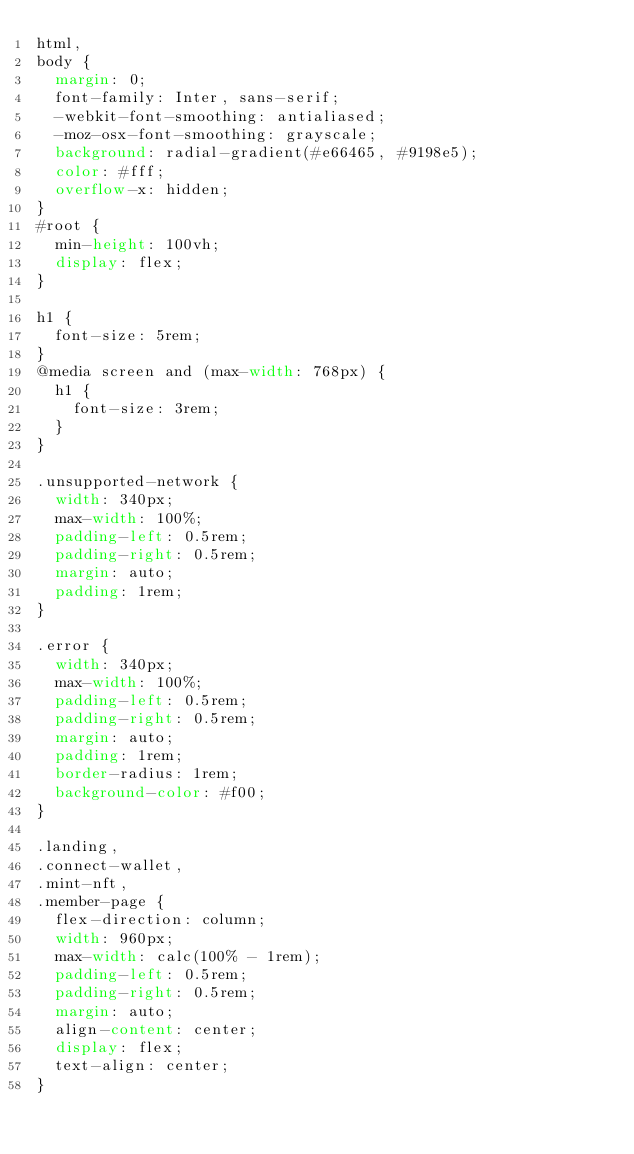<code> <loc_0><loc_0><loc_500><loc_500><_CSS_>html,
body {
  margin: 0;
  font-family: Inter, sans-serif;
  -webkit-font-smoothing: antialiased;
  -moz-osx-font-smoothing: grayscale;
  background: radial-gradient(#e66465, #9198e5);
  color: #fff;
  overflow-x: hidden;
}
#root {
  min-height: 100vh;
  display: flex;
}

h1 {
  font-size: 5rem;
}
@media screen and (max-width: 768px) {
  h1 {
    font-size: 3rem;
  }
}

.unsupported-network {
  width: 340px;
  max-width: 100%;
  padding-left: 0.5rem;
  padding-right: 0.5rem;
  margin: auto;
  padding: 1rem;
}

.error {
  width: 340px;
  max-width: 100%;
  padding-left: 0.5rem;
  padding-right: 0.5rem;
  margin: auto;
  padding: 1rem;
  border-radius: 1rem;
  background-color: #f00;
}

.landing,
.connect-wallet,
.mint-nft,
.member-page {
  flex-direction: column;
  width: 960px;
  max-width: calc(100% - 1rem);
  padding-left: 0.5rem;
  padding-right: 0.5rem;
  margin: auto;
  align-content: center;
  display: flex;
  text-align: center;
}
</code> 